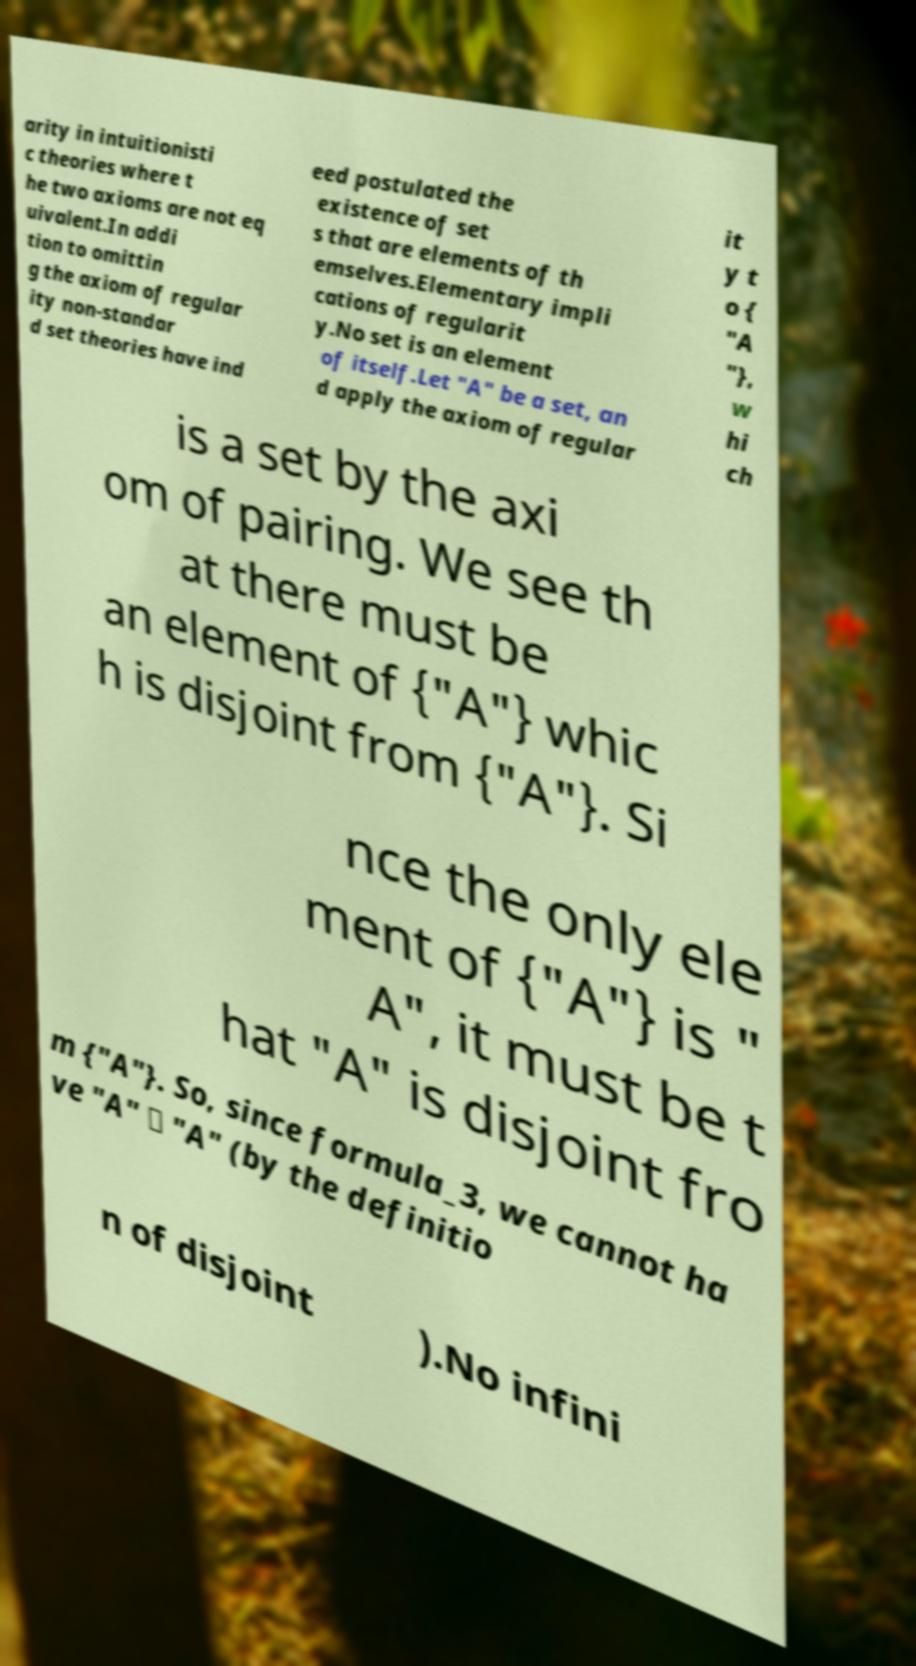Can you read and provide the text displayed in the image?This photo seems to have some interesting text. Can you extract and type it out for me? arity in intuitionisti c theories where t he two axioms are not eq uivalent.In addi tion to omittin g the axiom of regular ity non-standar d set theories have ind eed postulated the existence of set s that are elements of th emselves.Elementary impli cations of regularit y.No set is an element of itself.Let "A" be a set, an d apply the axiom of regular it y t o { "A "}, w hi ch is a set by the axi om of pairing. We see th at there must be an element of {"A"} whic h is disjoint from {"A"}. Si nce the only ele ment of {"A"} is " A", it must be t hat "A" is disjoint fro m {"A"}. So, since formula_3, we cannot ha ve "A" ∈ "A" (by the definitio n of disjoint ).No infini 